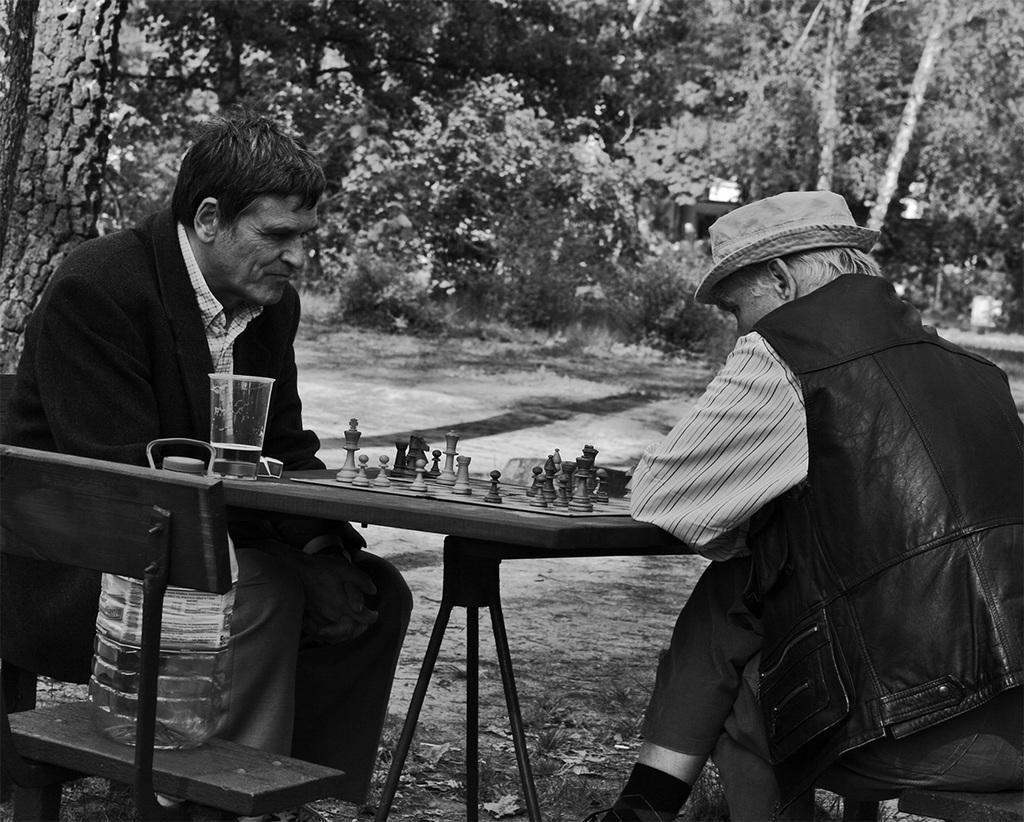In one or two sentences, can you explain what this image depicts? Black and white picture. Far there are trees. This 2 persons are sitting on a chair. In-front of them there is a table. On a table there is a chess board with chess coins. On this chair there is a water can. 